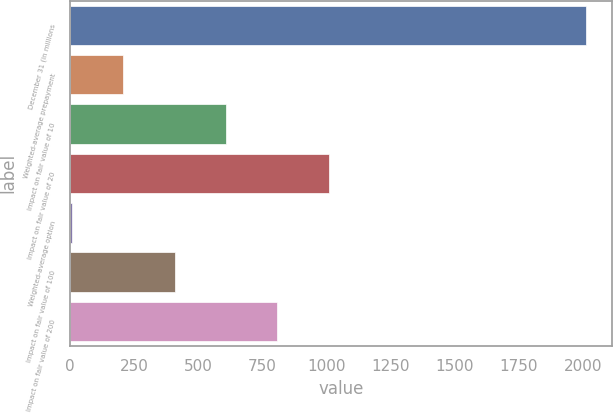Convert chart to OTSL. <chart><loc_0><loc_0><loc_500><loc_500><bar_chart><fcel>December 31 (in millions<fcel>Weighted-average prepayment<fcel>Impact on fair value of 10<fcel>Impact on fair value of 20<fcel>Weighted-average option<fcel>Impact on fair value of 100<fcel>Impact on fair value of 200<nl><fcel>2012<fcel>208.05<fcel>608.93<fcel>1009.81<fcel>7.61<fcel>408.49<fcel>809.37<nl></chart> 